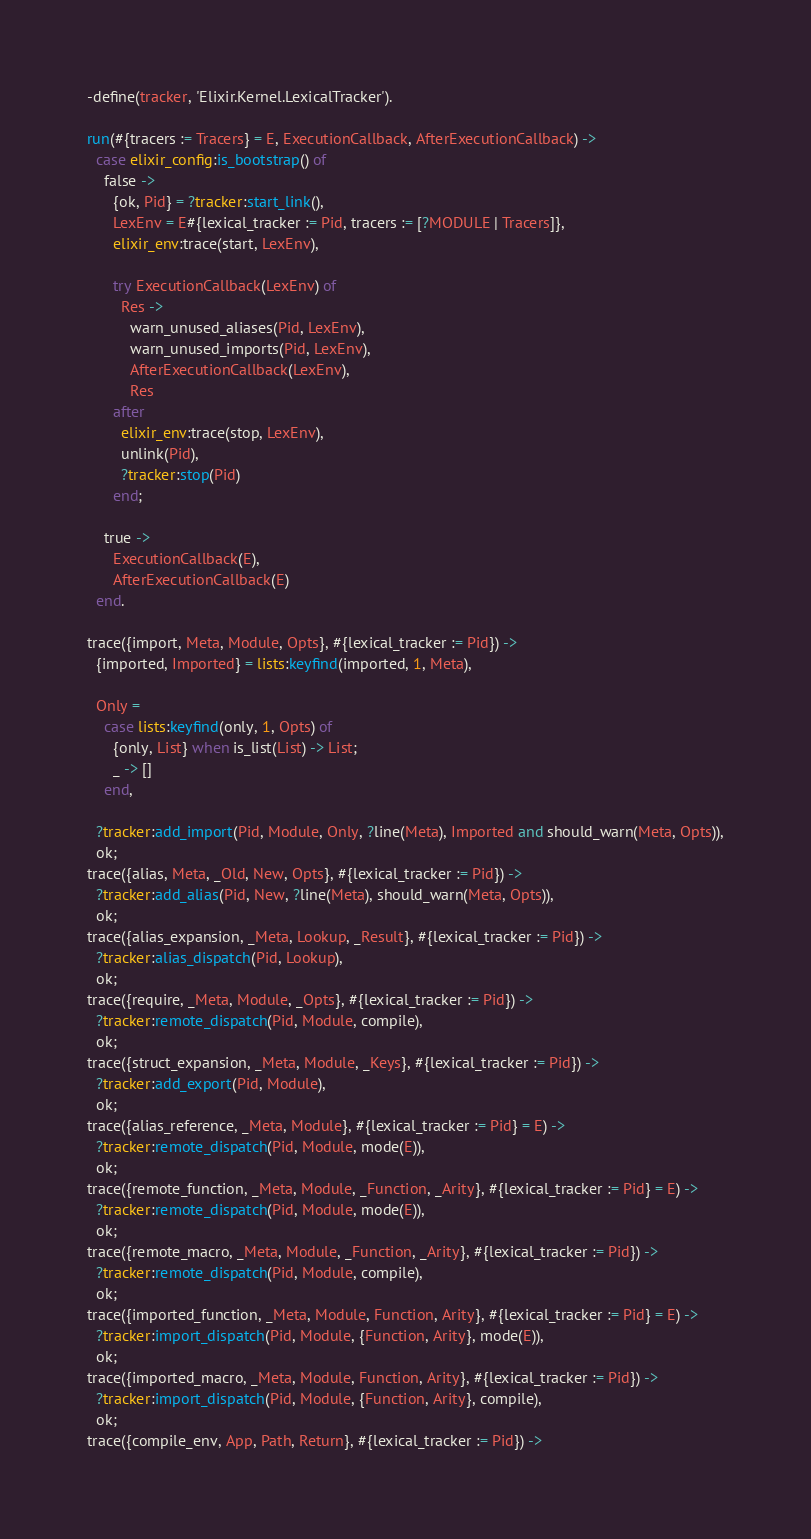Convert code to text. <code><loc_0><loc_0><loc_500><loc_500><_Erlang_>
-define(tracker, 'Elixir.Kernel.LexicalTracker').

run(#{tracers := Tracers} = E, ExecutionCallback, AfterExecutionCallback) ->
  case elixir_config:is_bootstrap() of
    false ->
      {ok, Pid} = ?tracker:start_link(),
      LexEnv = E#{lexical_tracker := Pid, tracers := [?MODULE | Tracers]},
      elixir_env:trace(start, LexEnv),

      try ExecutionCallback(LexEnv) of
        Res ->
          warn_unused_aliases(Pid, LexEnv),
          warn_unused_imports(Pid, LexEnv),
          AfterExecutionCallback(LexEnv),
          Res
      after
        elixir_env:trace(stop, LexEnv),
        unlink(Pid),
        ?tracker:stop(Pid)
      end;

    true ->
      ExecutionCallback(E),
      AfterExecutionCallback(E)
  end.

trace({import, Meta, Module, Opts}, #{lexical_tracker := Pid}) ->
  {imported, Imported} = lists:keyfind(imported, 1, Meta),

  Only =
    case lists:keyfind(only, 1, Opts) of
      {only, List} when is_list(List) -> List;
      _ -> []
    end,

  ?tracker:add_import(Pid, Module, Only, ?line(Meta), Imported and should_warn(Meta, Opts)),
  ok;
trace({alias, Meta, _Old, New, Opts}, #{lexical_tracker := Pid}) ->
  ?tracker:add_alias(Pid, New, ?line(Meta), should_warn(Meta, Opts)),
  ok;
trace({alias_expansion, _Meta, Lookup, _Result}, #{lexical_tracker := Pid}) ->
  ?tracker:alias_dispatch(Pid, Lookup),
  ok;
trace({require, _Meta, Module, _Opts}, #{lexical_tracker := Pid}) ->
  ?tracker:remote_dispatch(Pid, Module, compile),
  ok;
trace({struct_expansion, _Meta, Module, _Keys}, #{lexical_tracker := Pid}) ->
  ?tracker:add_export(Pid, Module),
  ok;
trace({alias_reference, _Meta, Module}, #{lexical_tracker := Pid} = E) ->
  ?tracker:remote_dispatch(Pid, Module, mode(E)),
  ok;
trace({remote_function, _Meta, Module, _Function, _Arity}, #{lexical_tracker := Pid} = E) ->
  ?tracker:remote_dispatch(Pid, Module, mode(E)),
  ok;
trace({remote_macro, _Meta, Module, _Function, _Arity}, #{lexical_tracker := Pid}) ->
  ?tracker:remote_dispatch(Pid, Module, compile),
  ok;
trace({imported_function, _Meta, Module, Function, Arity}, #{lexical_tracker := Pid} = E) ->
  ?tracker:import_dispatch(Pid, Module, {Function, Arity}, mode(E)),
  ok;
trace({imported_macro, _Meta, Module, Function, Arity}, #{lexical_tracker := Pid}) ->
  ?tracker:import_dispatch(Pid, Module, {Function, Arity}, compile),
  ok;
trace({compile_env, App, Path, Return}, #{lexical_tracker := Pid}) -></code> 